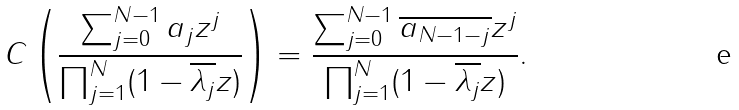<formula> <loc_0><loc_0><loc_500><loc_500>C \left ( \frac { \sum _ { j = 0 } ^ { N - 1 } a _ { j } z ^ { j } } { \prod _ { j = 1 } ^ { N } ( 1 - \overline { \lambda _ { j } } z ) } \right ) = \frac { \sum _ { j = 0 } ^ { N - 1 } \overline { a _ { N - 1 - j } } z ^ { j } } { \prod _ { j = 1 } ^ { N } ( 1 - \overline { \lambda _ { j } } z ) } .</formula> 